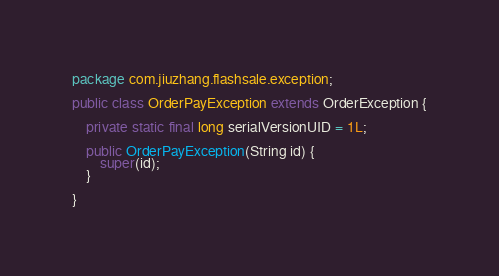<code> <loc_0><loc_0><loc_500><loc_500><_Java_>package com.jiuzhang.flashsale.exception;

public class OrderPayException extends OrderException {

    private static final long serialVersionUID = 1L;

    public OrderPayException(String id) {
        super(id);
    }

}
</code> 